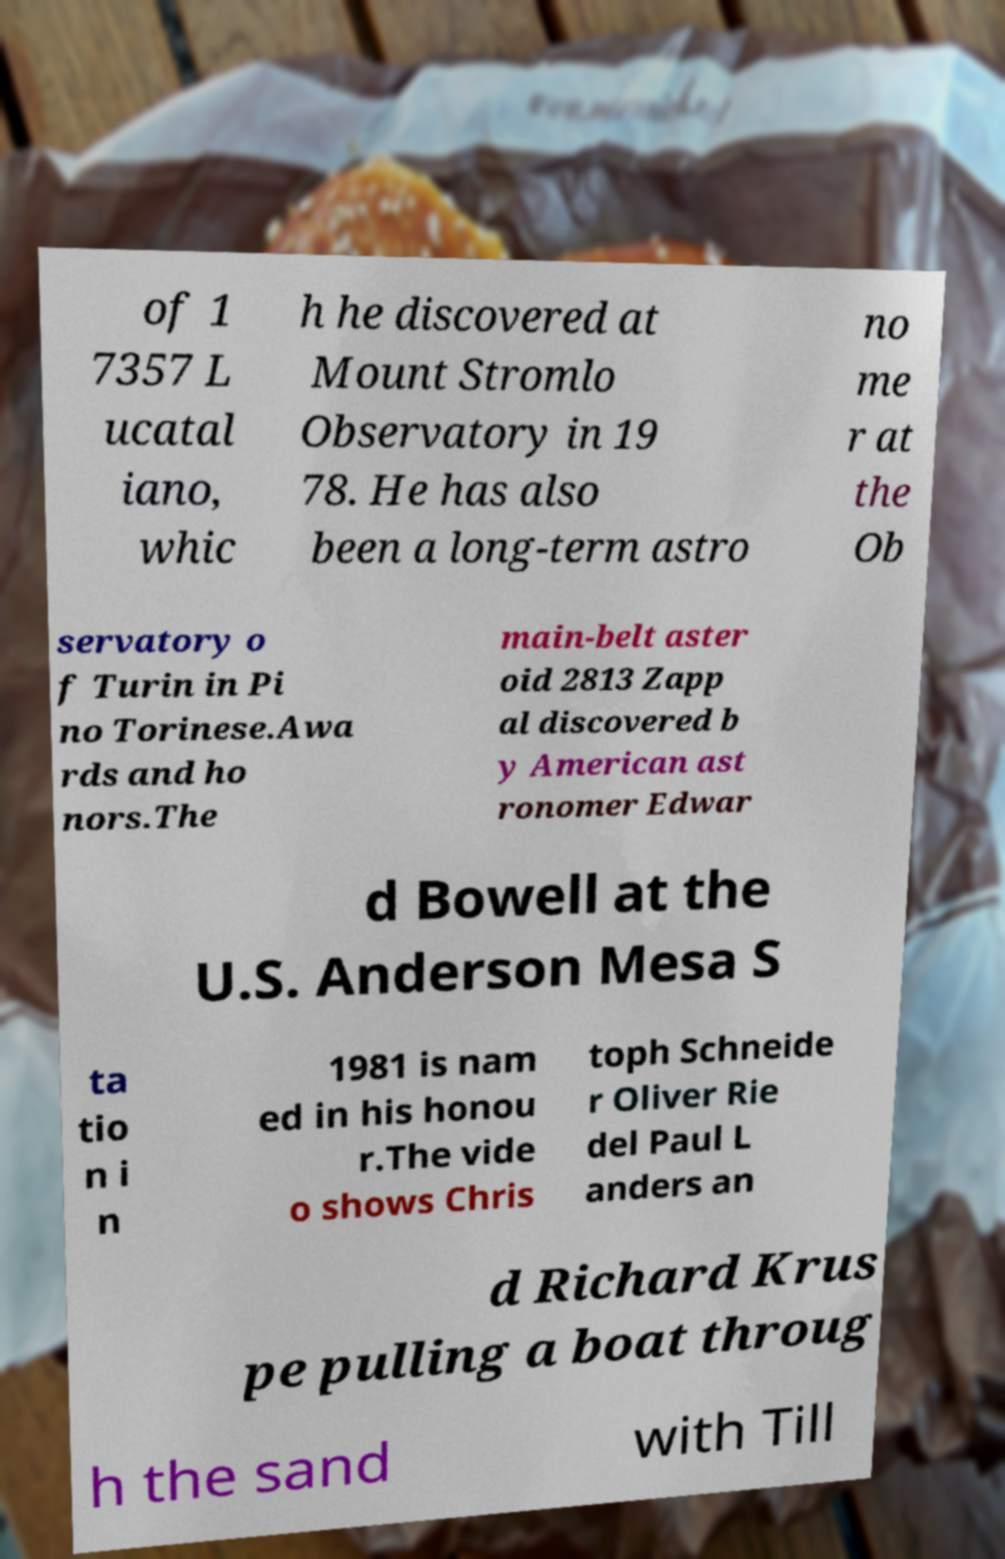Can you read and provide the text displayed in the image?This photo seems to have some interesting text. Can you extract and type it out for me? of 1 7357 L ucatal iano, whic h he discovered at Mount Stromlo Observatory in 19 78. He has also been a long-term astro no me r at the Ob servatory o f Turin in Pi no Torinese.Awa rds and ho nors.The main-belt aster oid 2813 Zapp al discovered b y American ast ronomer Edwar d Bowell at the U.S. Anderson Mesa S ta tio n i n 1981 is nam ed in his honou r.The vide o shows Chris toph Schneide r Oliver Rie del Paul L anders an d Richard Krus pe pulling a boat throug h the sand with Till 